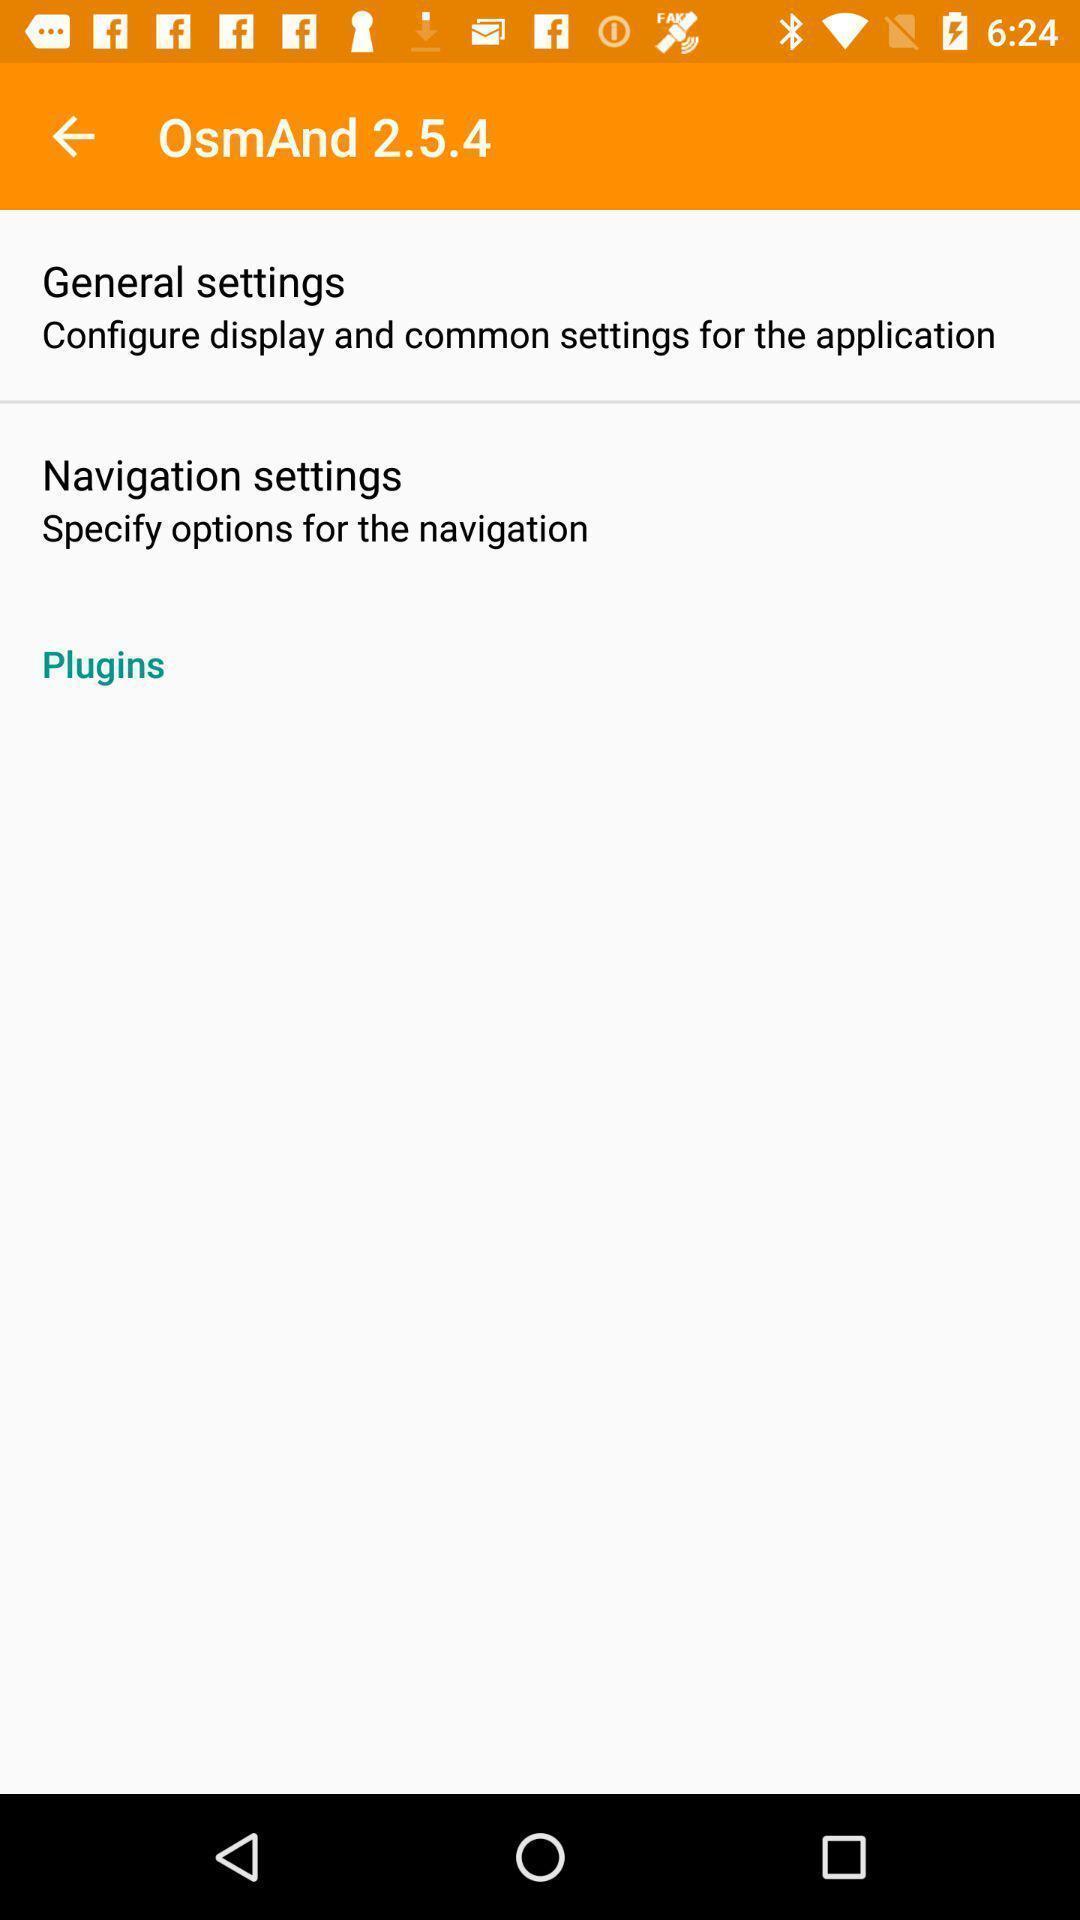Summarize the information in this screenshot. Window displaying offline navigation app. 